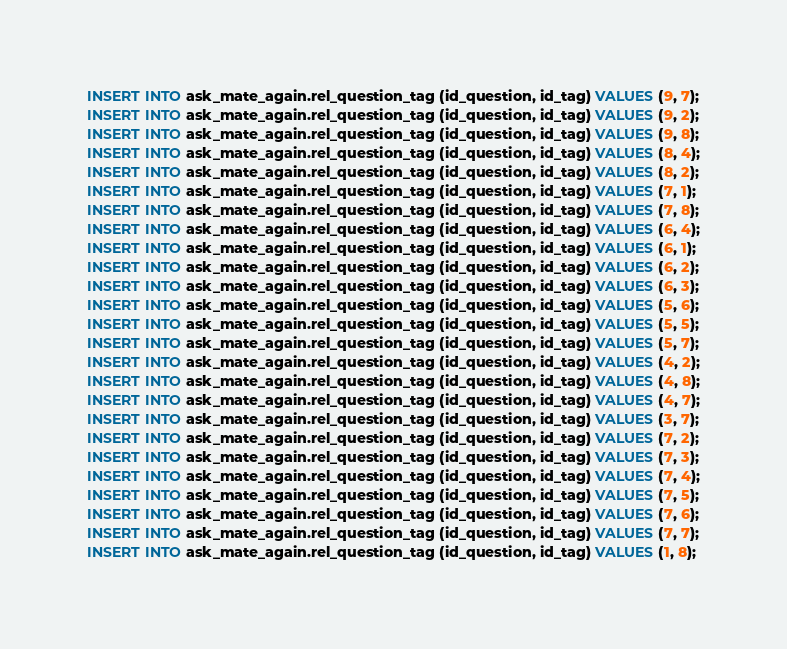Convert code to text. <code><loc_0><loc_0><loc_500><loc_500><_SQL_>INSERT INTO ask_mate_again.rel_question_tag (id_question, id_tag) VALUES (9, 7);
INSERT INTO ask_mate_again.rel_question_tag (id_question, id_tag) VALUES (9, 2);
INSERT INTO ask_mate_again.rel_question_tag (id_question, id_tag) VALUES (9, 8);
INSERT INTO ask_mate_again.rel_question_tag (id_question, id_tag) VALUES (8, 4);
INSERT INTO ask_mate_again.rel_question_tag (id_question, id_tag) VALUES (8, 2);
INSERT INTO ask_mate_again.rel_question_tag (id_question, id_tag) VALUES (7, 1);
INSERT INTO ask_mate_again.rel_question_tag (id_question, id_tag) VALUES (7, 8);
INSERT INTO ask_mate_again.rel_question_tag (id_question, id_tag) VALUES (6, 4);
INSERT INTO ask_mate_again.rel_question_tag (id_question, id_tag) VALUES (6, 1);
INSERT INTO ask_mate_again.rel_question_tag (id_question, id_tag) VALUES (6, 2);
INSERT INTO ask_mate_again.rel_question_tag (id_question, id_tag) VALUES (6, 3);
INSERT INTO ask_mate_again.rel_question_tag (id_question, id_tag) VALUES (5, 6);
INSERT INTO ask_mate_again.rel_question_tag (id_question, id_tag) VALUES (5, 5);
INSERT INTO ask_mate_again.rel_question_tag (id_question, id_tag) VALUES (5, 7);
INSERT INTO ask_mate_again.rel_question_tag (id_question, id_tag) VALUES (4, 2);
INSERT INTO ask_mate_again.rel_question_tag (id_question, id_tag) VALUES (4, 8);
INSERT INTO ask_mate_again.rel_question_tag (id_question, id_tag) VALUES (4, 7);
INSERT INTO ask_mate_again.rel_question_tag (id_question, id_tag) VALUES (3, 7);
INSERT INTO ask_mate_again.rel_question_tag (id_question, id_tag) VALUES (7, 2);
INSERT INTO ask_mate_again.rel_question_tag (id_question, id_tag) VALUES (7, 3);
INSERT INTO ask_mate_again.rel_question_tag (id_question, id_tag) VALUES (7, 4);
INSERT INTO ask_mate_again.rel_question_tag (id_question, id_tag) VALUES (7, 5);
INSERT INTO ask_mate_again.rel_question_tag (id_question, id_tag) VALUES (7, 6);
INSERT INTO ask_mate_again.rel_question_tag (id_question, id_tag) VALUES (7, 7);
INSERT INTO ask_mate_again.rel_question_tag (id_question, id_tag) VALUES (1, 8);</code> 